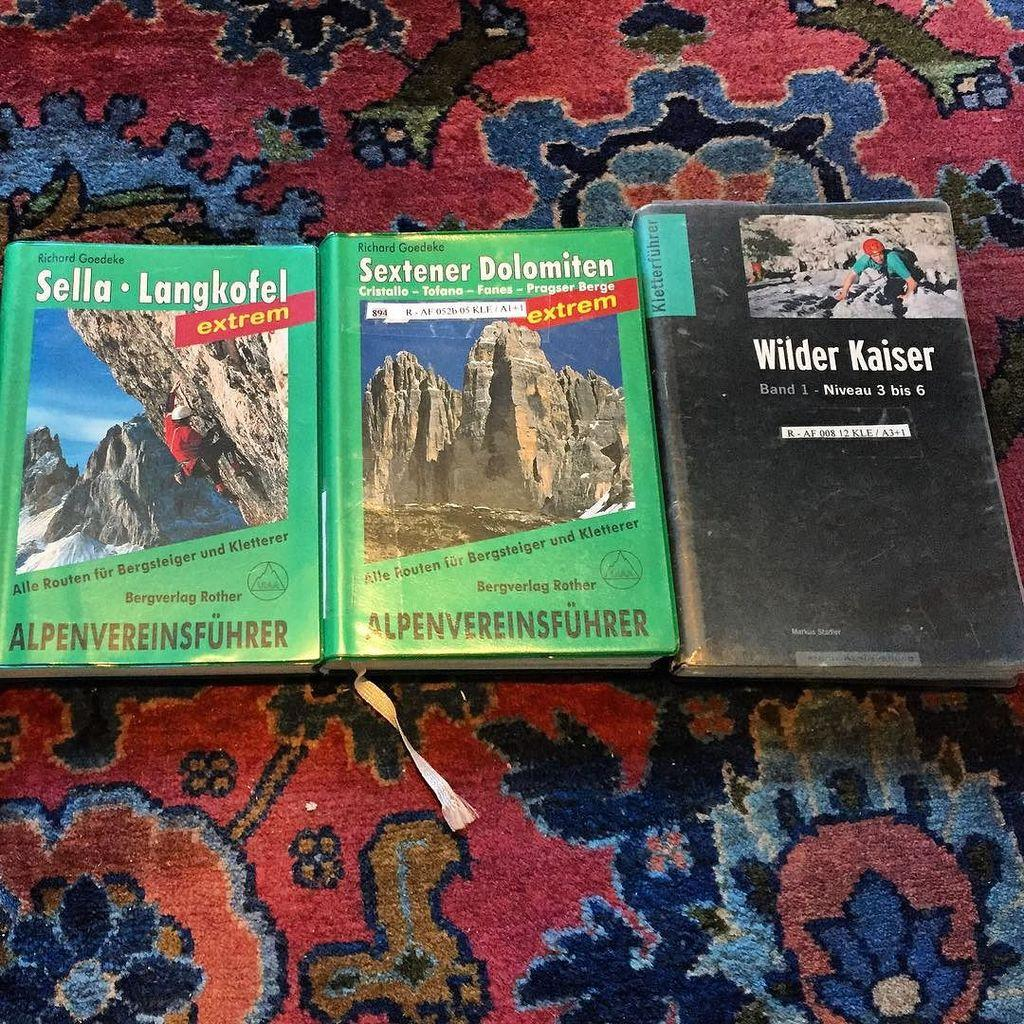<image>
Provide a brief description of the given image. A book has Wilder Kaiser on the front in white letters. 